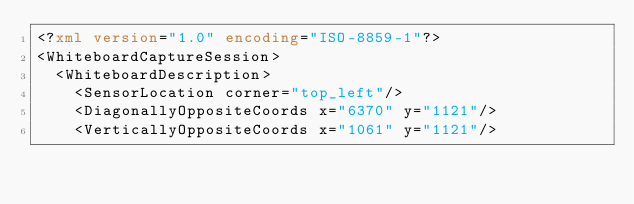Convert code to text. <code><loc_0><loc_0><loc_500><loc_500><_XML_><?xml version="1.0" encoding="ISO-8859-1"?>
<WhiteboardCaptureSession>
  <WhiteboardDescription>
    <SensorLocation corner="top_left"/>
    <DiagonallyOppositeCoords x="6370" y="1121"/>
    <VerticallyOppositeCoords x="1061" y="1121"/></code> 